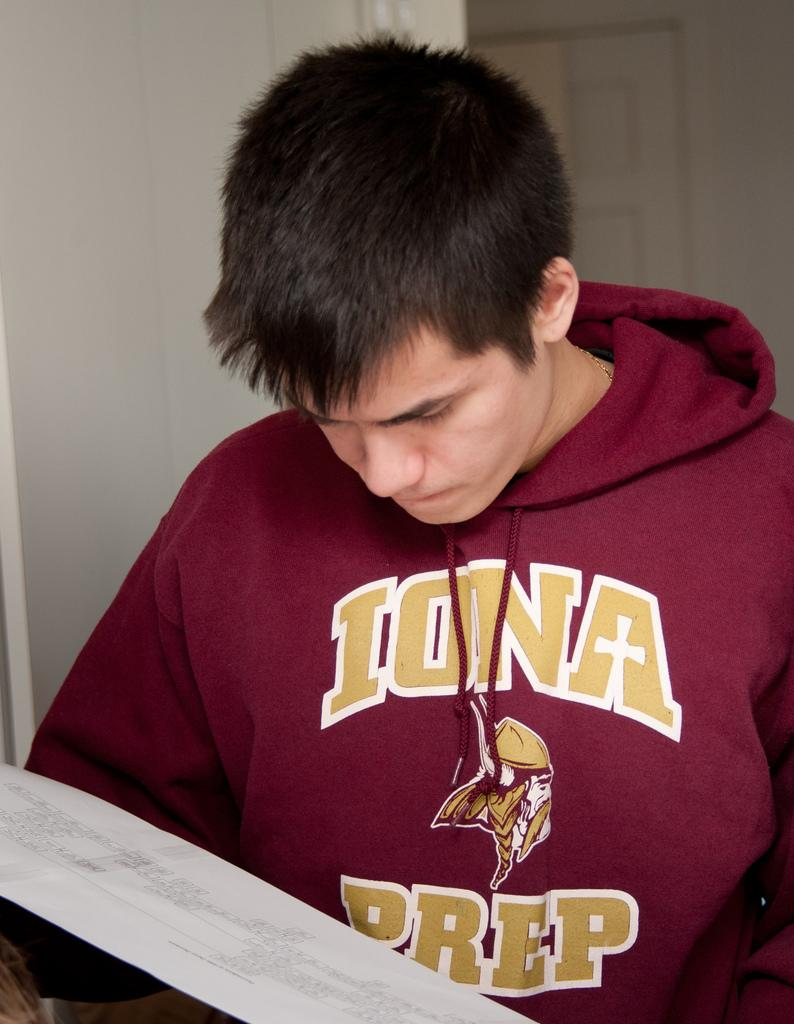Provide a one-sentence caption for the provided image. A man wearing a red Iona Prep sweatshirt. 